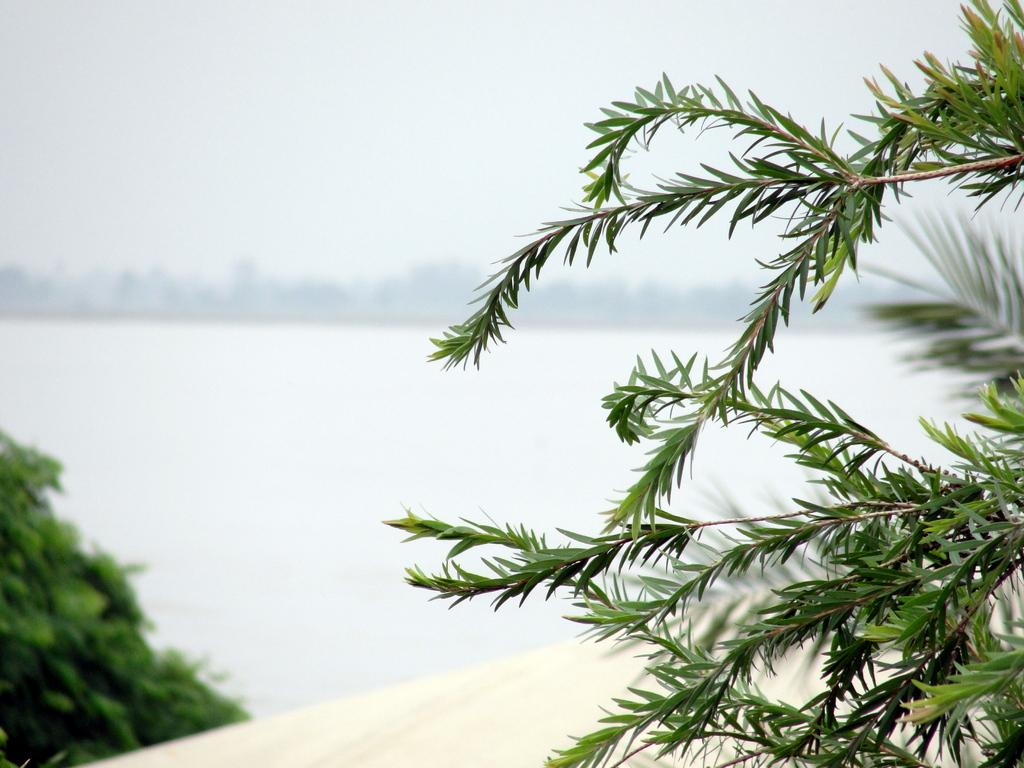What type of vegetation is on the right side of the image? There is a tree on the right side of the image. What natural feature can be seen in the background of the image? There is a river in the background of the image. What else is visible in the background of the image? The sky is visible in the background of the image. What type of scarf is being used to teach the tree how to swim in the river? There is no scarf or swimming lesson depicted in the image; it features a tree on the right side, a river in the background, and the sky visible. 